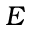<formula> <loc_0><loc_0><loc_500><loc_500>E</formula> 